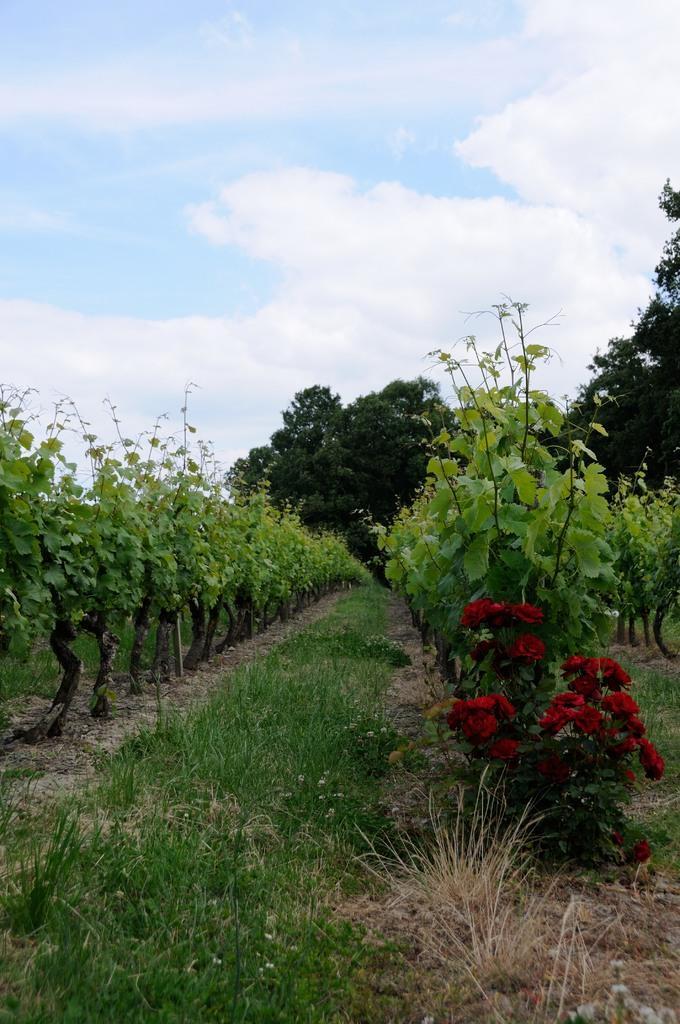Could you give a brief overview of what you see in this image? In this image there are plants rose flowers, trees and the sky. 